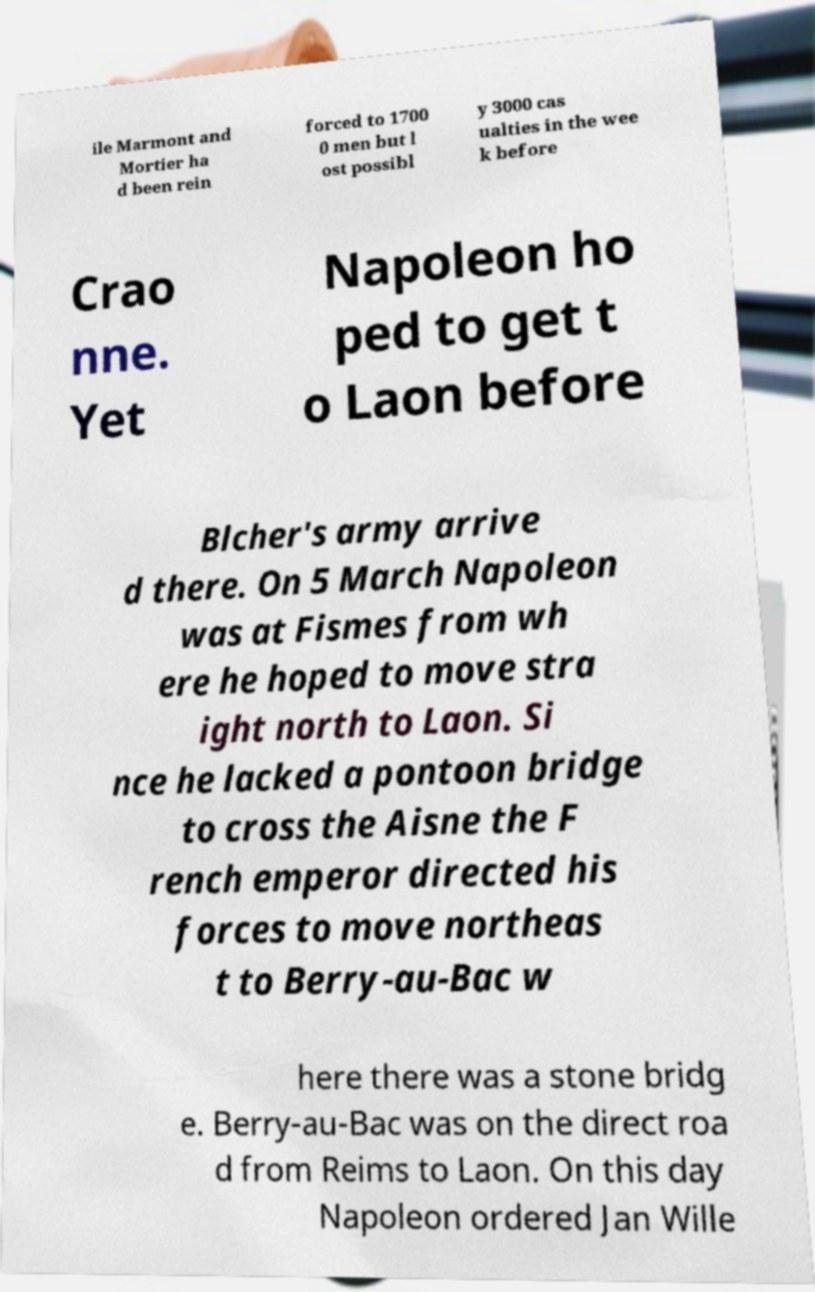For documentation purposes, I need the text within this image transcribed. Could you provide that? ile Marmont and Mortier ha d been rein forced to 1700 0 men but l ost possibl y 3000 cas ualties in the wee k before Crao nne. Yet Napoleon ho ped to get t o Laon before Blcher's army arrive d there. On 5 March Napoleon was at Fismes from wh ere he hoped to move stra ight north to Laon. Si nce he lacked a pontoon bridge to cross the Aisne the F rench emperor directed his forces to move northeas t to Berry-au-Bac w here there was a stone bridg e. Berry-au-Bac was on the direct roa d from Reims to Laon. On this day Napoleon ordered Jan Wille 